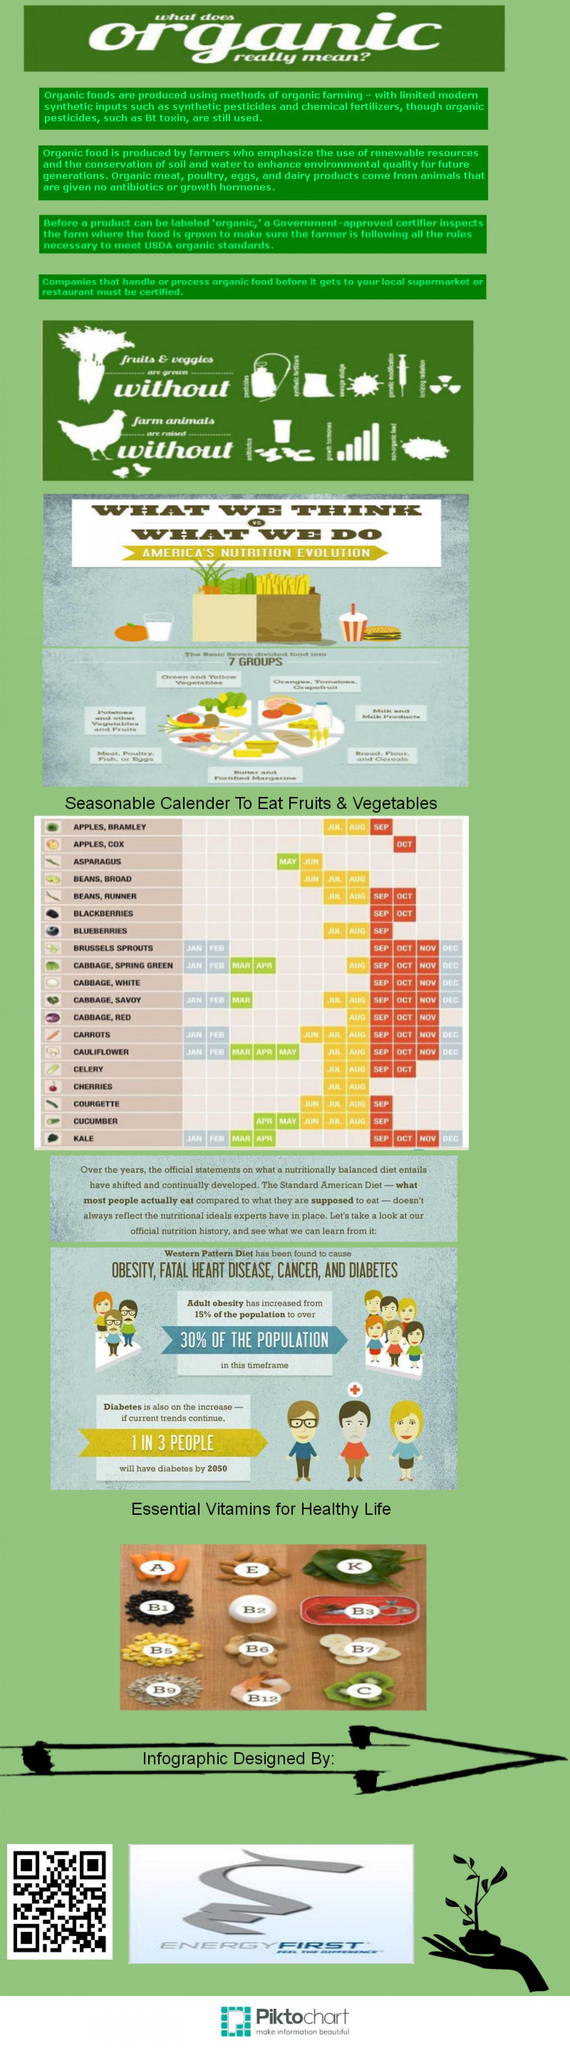Give some essential details in this illustration. There are eight types of vitamin B mentioned in this infographic. The infographic mentions 12 essential vitamins. The source of vitamin E is either an egg or almonds, with almonds being the correct answer. The carrot is the source of vitamin A, while almonds do not contain this essential nutrient. 